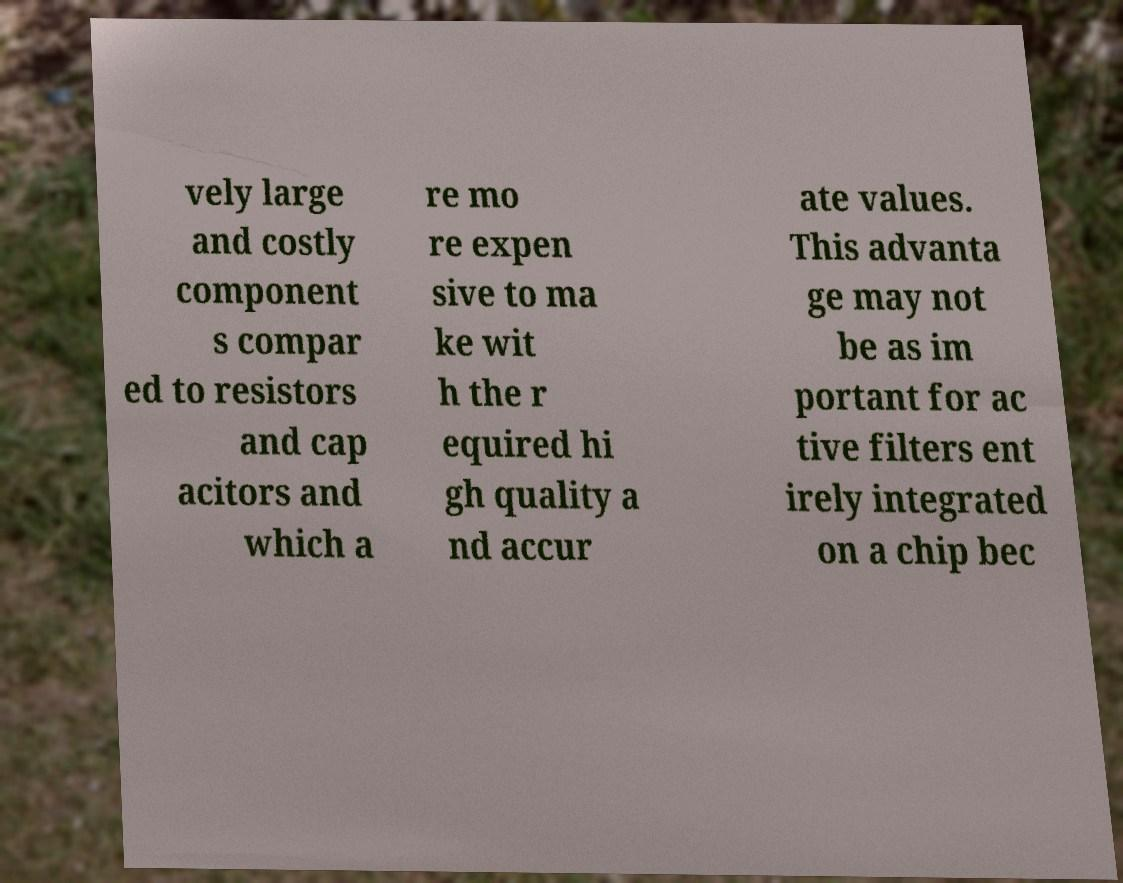Can you accurately transcribe the text from the provided image for me? vely large and costly component s compar ed to resistors and cap acitors and which a re mo re expen sive to ma ke wit h the r equired hi gh quality a nd accur ate values. This advanta ge may not be as im portant for ac tive filters ent irely integrated on a chip bec 